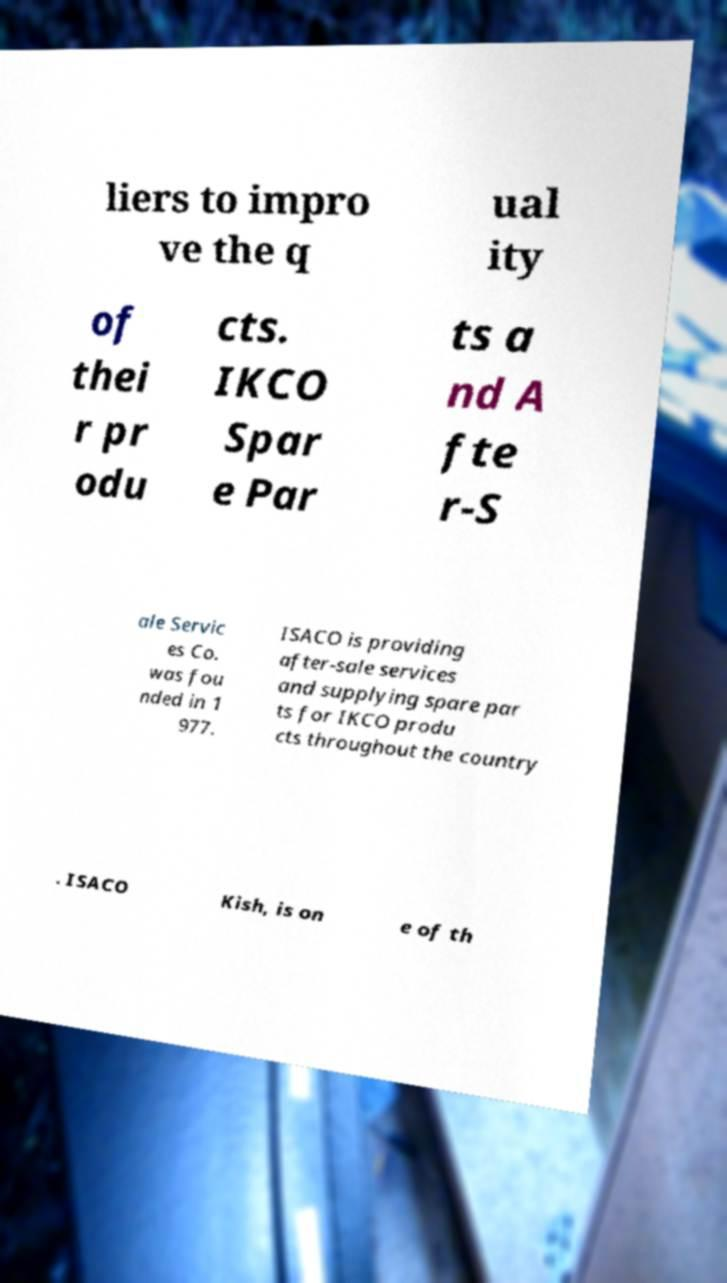Could you assist in decoding the text presented in this image and type it out clearly? liers to impro ve the q ual ity of thei r pr odu cts. IKCO Spar e Par ts a nd A fte r-S ale Servic es Co. was fou nded in 1 977. ISACO is providing after-sale services and supplying spare par ts for IKCO produ cts throughout the country . ISACO Kish, is on e of th 